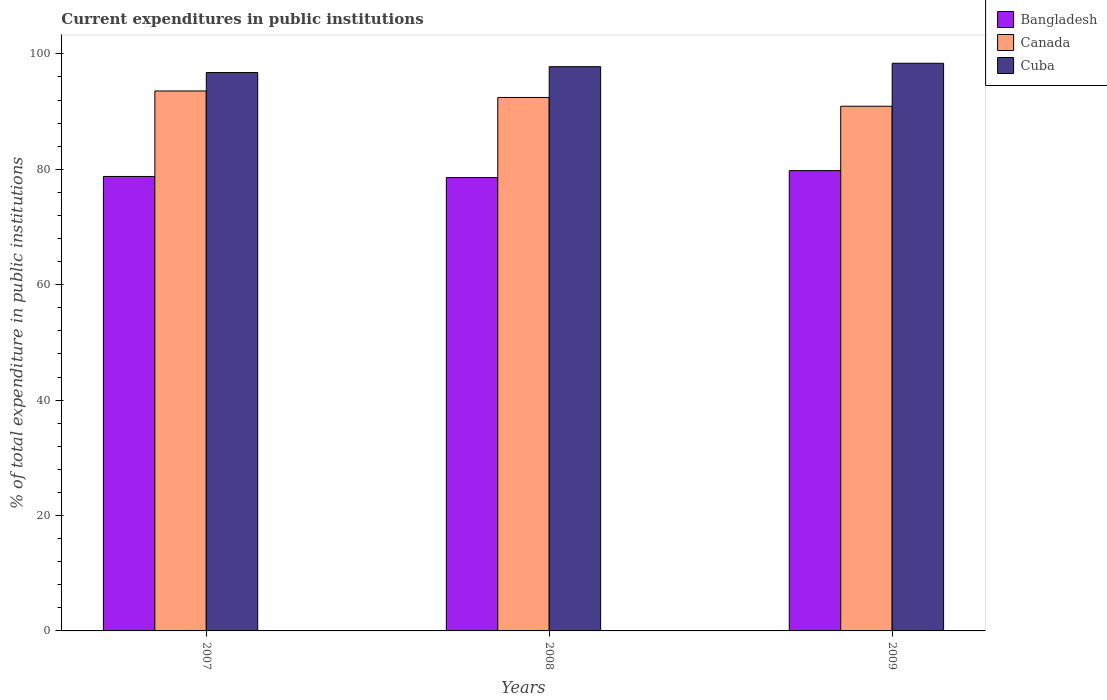How many groups of bars are there?
Give a very brief answer. 3. Are the number of bars per tick equal to the number of legend labels?
Provide a succinct answer. Yes. Are the number of bars on each tick of the X-axis equal?
Ensure brevity in your answer.  Yes. How many bars are there on the 2nd tick from the left?
Keep it short and to the point. 3. In how many cases, is the number of bars for a given year not equal to the number of legend labels?
Make the answer very short. 0. What is the current expenditures in public institutions in Cuba in 2007?
Offer a very short reply. 96.77. Across all years, what is the maximum current expenditures in public institutions in Bangladesh?
Provide a short and direct response. 79.77. Across all years, what is the minimum current expenditures in public institutions in Canada?
Offer a very short reply. 90.93. In which year was the current expenditures in public institutions in Canada maximum?
Your response must be concise. 2007. In which year was the current expenditures in public institutions in Cuba minimum?
Your response must be concise. 2007. What is the total current expenditures in public institutions in Cuba in the graph?
Your answer should be very brief. 292.93. What is the difference between the current expenditures in public institutions in Cuba in 2007 and that in 2008?
Ensure brevity in your answer.  -1.01. What is the difference between the current expenditures in public institutions in Bangladesh in 2007 and the current expenditures in public institutions in Canada in 2009?
Give a very brief answer. -12.17. What is the average current expenditures in public institutions in Cuba per year?
Your answer should be compact. 97.64. In the year 2009, what is the difference between the current expenditures in public institutions in Bangladesh and current expenditures in public institutions in Canada?
Keep it short and to the point. -11.15. What is the ratio of the current expenditures in public institutions in Canada in 2008 to that in 2009?
Offer a very short reply. 1.02. Is the current expenditures in public institutions in Bangladesh in 2008 less than that in 2009?
Offer a very short reply. Yes. Is the difference between the current expenditures in public institutions in Bangladesh in 2008 and 2009 greater than the difference between the current expenditures in public institutions in Canada in 2008 and 2009?
Ensure brevity in your answer.  No. What is the difference between the highest and the second highest current expenditures in public institutions in Cuba?
Offer a very short reply. 0.59. What is the difference between the highest and the lowest current expenditures in public institutions in Cuba?
Make the answer very short. 1.61. Is the sum of the current expenditures in public institutions in Cuba in 2007 and 2009 greater than the maximum current expenditures in public institutions in Bangladesh across all years?
Provide a short and direct response. Yes. What does the 2nd bar from the left in 2007 represents?
Your response must be concise. Canada. What does the 2nd bar from the right in 2008 represents?
Provide a short and direct response. Canada. How many bars are there?
Your response must be concise. 9. How many years are there in the graph?
Your answer should be very brief. 3. Does the graph contain grids?
Offer a terse response. No. How many legend labels are there?
Provide a short and direct response. 3. How are the legend labels stacked?
Your answer should be very brief. Vertical. What is the title of the graph?
Your answer should be very brief. Current expenditures in public institutions. What is the label or title of the Y-axis?
Give a very brief answer. % of total expenditure in public institutions. What is the % of total expenditure in public institutions of Bangladesh in 2007?
Keep it short and to the point. 78.76. What is the % of total expenditure in public institutions in Canada in 2007?
Your answer should be very brief. 93.57. What is the % of total expenditure in public institutions of Cuba in 2007?
Offer a terse response. 96.77. What is the % of total expenditure in public institutions of Bangladesh in 2008?
Provide a short and direct response. 78.56. What is the % of total expenditure in public institutions in Canada in 2008?
Provide a succinct answer. 92.45. What is the % of total expenditure in public institutions of Cuba in 2008?
Provide a succinct answer. 97.78. What is the % of total expenditure in public institutions in Bangladesh in 2009?
Your answer should be compact. 79.77. What is the % of total expenditure in public institutions in Canada in 2009?
Offer a terse response. 90.93. What is the % of total expenditure in public institutions in Cuba in 2009?
Provide a short and direct response. 98.38. Across all years, what is the maximum % of total expenditure in public institutions of Bangladesh?
Your response must be concise. 79.77. Across all years, what is the maximum % of total expenditure in public institutions in Canada?
Provide a short and direct response. 93.57. Across all years, what is the maximum % of total expenditure in public institutions of Cuba?
Provide a short and direct response. 98.38. Across all years, what is the minimum % of total expenditure in public institutions of Bangladesh?
Keep it short and to the point. 78.56. Across all years, what is the minimum % of total expenditure in public institutions of Canada?
Your response must be concise. 90.93. Across all years, what is the minimum % of total expenditure in public institutions in Cuba?
Offer a very short reply. 96.77. What is the total % of total expenditure in public institutions of Bangladesh in the graph?
Provide a short and direct response. 237.09. What is the total % of total expenditure in public institutions of Canada in the graph?
Your response must be concise. 276.95. What is the total % of total expenditure in public institutions in Cuba in the graph?
Make the answer very short. 292.93. What is the difference between the % of total expenditure in public institutions in Bangladesh in 2007 and that in 2008?
Make the answer very short. 0.19. What is the difference between the % of total expenditure in public institutions in Canada in 2007 and that in 2008?
Make the answer very short. 1.12. What is the difference between the % of total expenditure in public institutions of Cuba in 2007 and that in 2008?
Your response must be concise. -1.01. What is the difference between the % of total expenditure in public institutions in Bangladesh in 2007 and that in 2009?
Give a very brief answer. -1.01. What is the difference between the % of total expenditure in public institutions of Canada in 2007 and that in 2009?
Offer a terse response. 2.65. What is the difference between the % of total expenditure in public institutions in Cuba in 2007 and that in 2009?
Ensure brevity in your answer.  -1.61. What is the difference between the % of total expenditure in public institutions in Bangladesh in 2008 and that in 2009?
Offer a very short reply. -1.21. What is the difference between the % of total expenditure in public institutions in Canada in 2008 and that in 2009?
Ensure brevity in your answer.  1.52. What is the difference between the % of total expenditure in public institutions in Cuba in 2008 and that in 2009?
Your response must be concise. -0.59. What is the difference between the % of total expenditure in public institutions in Bangladesh in 2007 and the % of total expenditure in public institutions in Canada in 2008?
Offer a very short reply. -13.69. What is the difference between the % of total expenditure in public institutions of Bangladesh in 2007 and the % of total expenditure in public institutions of Cuba in 2008?
Offer a terse response. -19.02. What is the difference between the % of total expenditure in public institutions of Canada in 2007 and the % of total expenditure in public institutions of Cuba in 2008?
Your answer should be compact. -4.21. What is the difference between the % of total expenditure in public institutions of Bangladesh in 2007 and the % of total expenditure in public institutions of Canada in 2009?
Ensure brevity in your answer.  -12.17. What is the difference between the % of total expenditure in public institutions in Bangladesh in 2007 and the % of total expenditure in public institutions in Cuba in 2009?
Your answer should be compact. -19.62. What is the difference between the % of total expenditure in public institutions in Canada in 2007 and the % of total expenditure in public institutions in Cuba in 2009?
Give a very brief answer. -4.8. What is the difference between the % of total expenditure in public institutions of Bangladesh in 2008 and the % of total expenditure in public institutions of Canada in 2009?
Offer a terse response. -12.36. What is the difference between the % of total expenditure in public institutions of Bangladesh in 2008 and the % of total expenditure in public institutions of Cuba in 2009?
Keep it short and to the point. -19.81. What is the difference between the % of total expenditure in public institutions of Canada in 2008 and the % of total expenditure in public institutions of Cuba in 2009?
Give a very brief answer. -5.93. What is the average % of total expenditure in public institutions of Bangladesh per year?
Offer a terse response. 79.03. What is the average % of total expenditure in public institutions in Canada per year?
Your answer should be very brief. 92.32. What is the average % of total expenditure in public institutions in Cuba per year?
Offer a terse response. 97.64. In the year 2007, what is the difference between the % of total expenditure in public institutions of Bangladesh and % of total expenditure in public institutions of Canada?
Provide a succinct answer. -14.81. In the year 2007, what is the difference between the % of total expenditure in public institutions in Bangladesh and % of total expenditure in public institutions in Cuba?
Ensure brevity in your answer.  -18.01. In the year 2007, what is the difference between the % of total expenditure in public institutions in Canada and % of total expenditure in public institutions in Cuba?
Your answer should be compact. -3.2. In the year 2008, what is the difference between the % of total expenditure in public institutions in Bangladesh and % of total expenditure in public institutions in Canada?
Ensure brevity in your answer.  -13.88. In the year 2008, what is the difference between the % of total expenditure in public institutions in Bangladesh and % of total expenditure in public institutions in Cuba?
Keep it short and to the point. -19.22. In the year 2008, what is the difference between the % of total expenditure in public institutions in Canada and % of total expenditure in public institutions in Cuba?
Give a very brief answer. -5.33. In the year 2009, what is the difference between the % of total expenditure in public institutions of Bangladesh and % of total expenditure in public institutions of Canada?
Provide a short and direct response. -11.15. In the year 2009, what is the difference between the % of total expenditure in public institutions of Bangladesh and % of total expenditure in public institutions of Cuba?
Your answer should be compact. -18.6. In the year 2009, what is the difference between the % of total expenditure in public institutions of Canada and % of total expenditure in public institutions of Cuba?
Offer a very short reply. -7.45. What is the ratio of the % of total expenditure in public institutions in Canada in 2007 to that in 2008?
Your answer should be very brief. 1.01. What is the ratio of the % of total expenditure in public institutions of Cuba in 2007 to that in 2008?
Make the answer very short. 0.99. What is the ratio of the % of total expenditure in public institutions in Bangladesh in 2007 to that in 2009?
Make the answer very short. 0.99. What is the ratio of the % of total expenditure in public institutions in Canada in 2007 to that in 2009?
Offer a terse response. 1.03. What is the ratio of the % of total expenditure in public institutions of Cuba in 2007 to that in 2009?
Provide a short and direct response. 0.98. What is the ratio of the % of total expenditure in public institutions in Bangladesh in 2008 to that in 2009?
Ensure brevity in your answer.  0.98. What is the ratio of the % of total expenditure in public institutions of Canada in 2008 to that in 2009?
Give a very brief answer. 1.02. What is the difference between the highest and the second highest % of total expenditure in public institutions in Bangladesh?
Provide a short and direct response. 1.01. What is the difference between the highest and the second highest % of total expenditure in public institutions of Canada?
Provide a short and direct response. 1.12. What is the difference between the highest and the second highest % of total expenditure in public institutions of Cuba?
Your answer should be very brief. 0.59. What is the difference between the highest and the lowest % of total expenditure in public institutions of Bangladesh?
Give a very brief answer. 1.21. What is the difference between the highest and the lowest % of total expenditure in public institutions of Canada?
Provide a short and direct response. 2.65. What is the difference between the highest and the lowest % of total expenditure in public institutions of Cuba?
Your response must be concise. 1.61. 